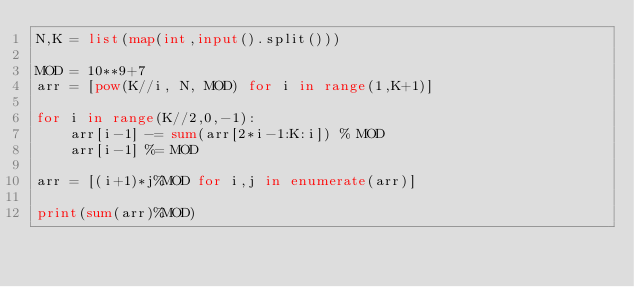Convert code to text. <code><loc_0><loc_0><loc_500><loc_500><_Python_>N,K = list(map(int,input().split()))

MOD = 10**9+7
arr = [pow(K//i, N, MOD) for i in range(1,K+1)]

for i in range(K//2,0,-1):
    arr[i-1] -= sum(arr[2*i-1:K:i]) % MOD
    arr[i-1] %= MOD
    
arr = [(i+1)*j%MOD for i,j in enumerate(arr)]

print(sum(arr)%MOD)</code> 